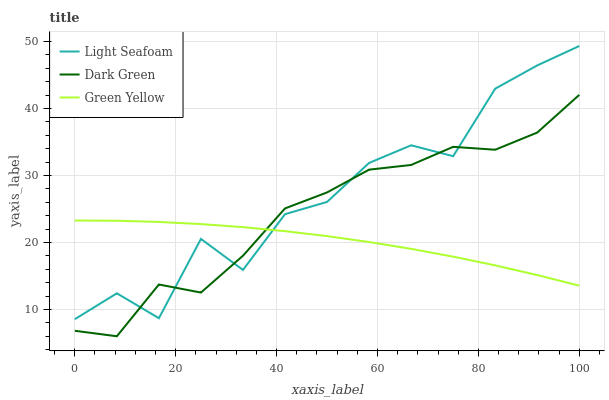Does Green Yellow have the minimum area under the curve?
Answer yes or no. Yes. Does Light Seafoam have the maximum area under the curve?
Answer yes or no. Yes. Does Dark Green have the minimum area under the curve?
Answer yes or no. No. Does Dark Green have the maximum area under the curve?
Answer yes or no. No. Is Green Yellow the smoothest?
Answer yes or no. Yes. Is Light Seafoam the roughest?
Answer yes or no. Yes. Is Dark Green the smoothest?
Answer yes or no. No. Is Dark Green the roughest?
Answer yes or no. No. Does Light Seafoam have the lowest value?
Answer yes or no. No. Does Light Seafoam have the highest value?
Answer yes or no. Yes. Does Dark Green have the highest value?
Answer yes or no. No. Does Green Yellow intersect Light Seafoam?
Answer yes or no. Yes. Is Green Yellow less than Light Seafoam?
Answer yes or no. No. Is Green Yellow greater than Light Seafoam?
Answer yes or no. No. 